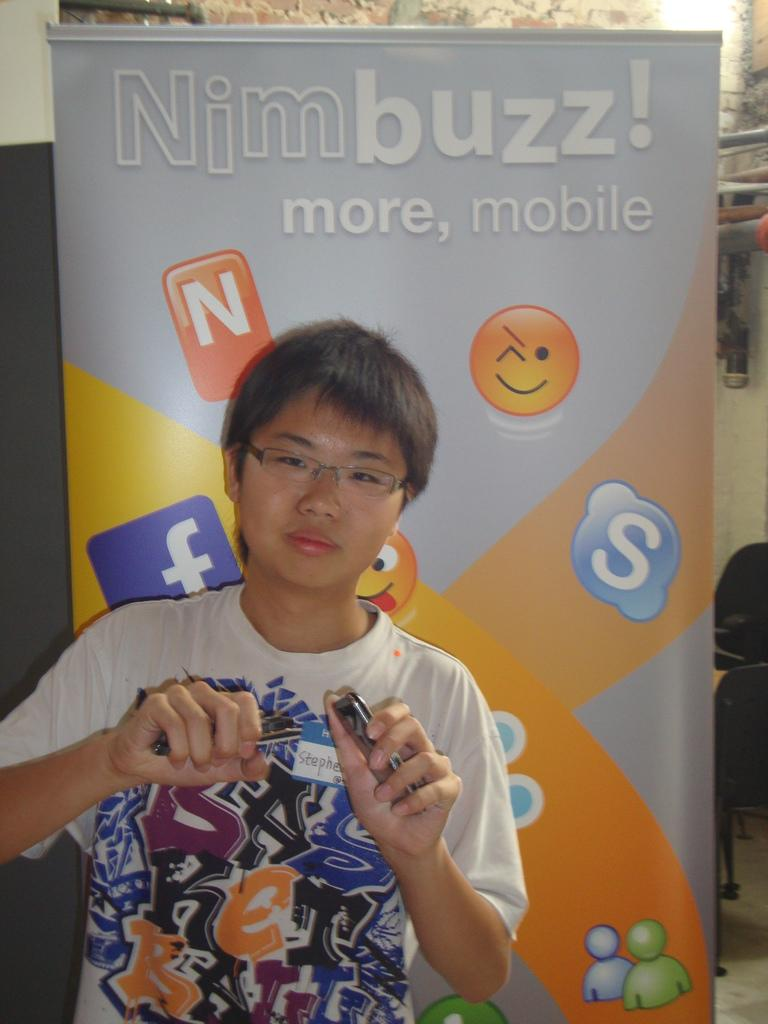<image>
Present a compact description of the photo's key features. a boy what the word nim buzz behind him 